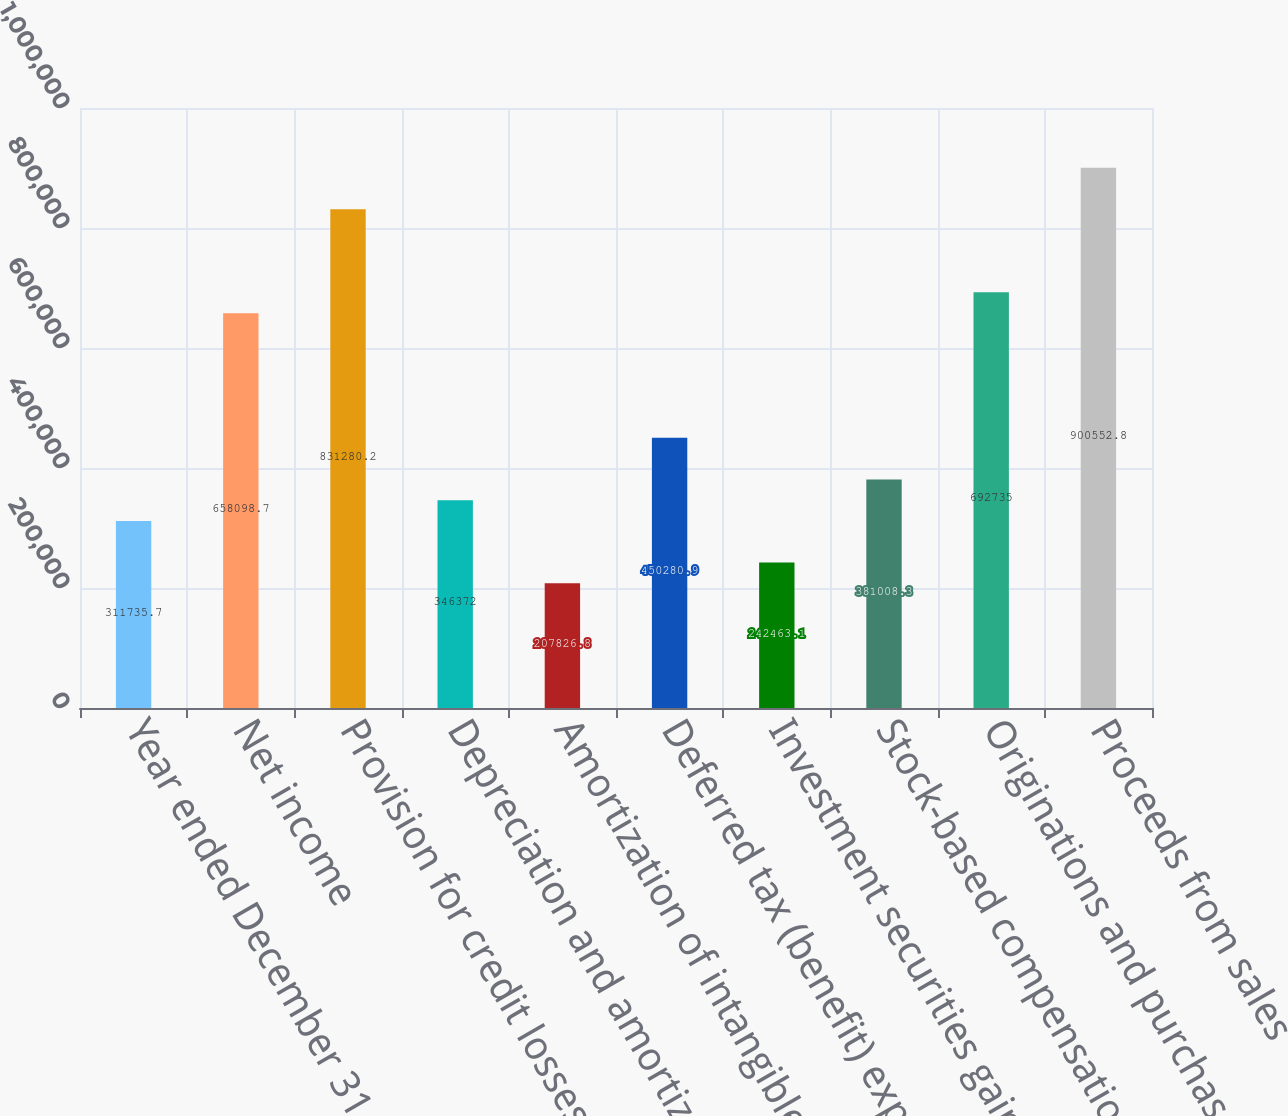Convert chart to OTSL. <chart><loc_0><loc_0><loc_500><loc_500><bar_chart><fcel>Year ended December 31 (in<fcel>Net income<fcel>Provision for credit losses<fcel>Depreciation and amortization<fcel>Amortization of intangibles<fcel>Deferred tax (benefit) expense<fcel>Investment securities gains<fcel>Stock-based compensation<fcel>Originations and purchases of<fcel>Proceeds from sales<nl><fcel>311736<fcel>658099<fcel>831280<fcel>346372<fcel>207827<fcel>450281<fcel>242463<fcel>381008<fcel>692735<fcel>900553<nl></chart> 